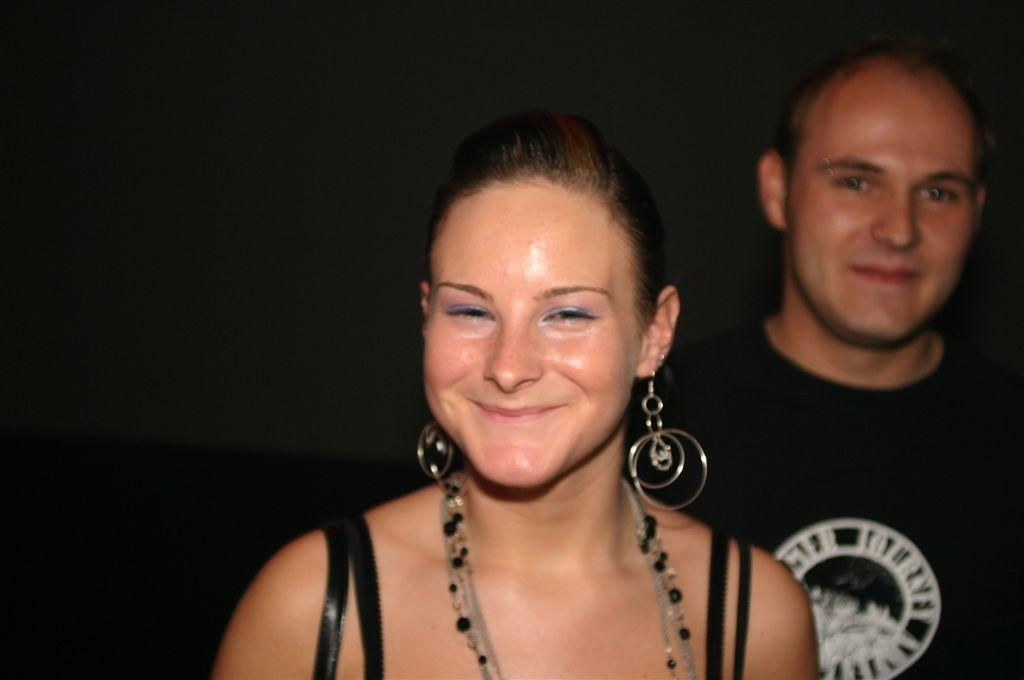Who is the main subject in the foreground of the picture? There is a woman in the foreground of the picture. What is the woman doing in the image? The woman is smiling. Can you describe the person in the background of the picture? There is a man in the background of the picture, and he is wearing a black t-shirt. What is the man doing in the image? The man is smiling. How would you describe the overall lighting in the image? The background of the image is dark. How many friends are in the crowd in the image? There is no crowd present in the image, and the concept of friends is not mentioned in the provided facts. 